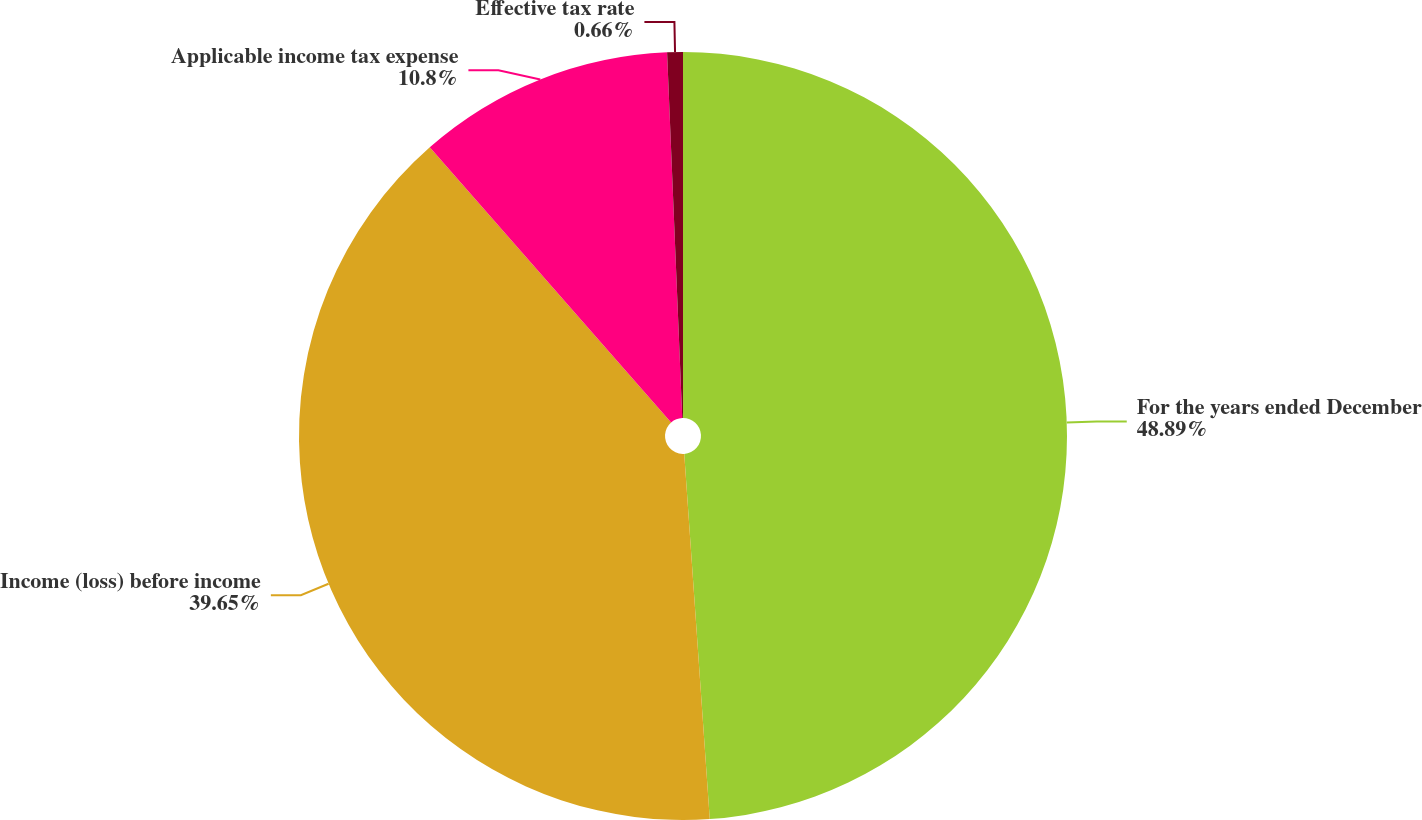Convert chart. <chart><loc_0><loc_0><loc_500><loc_500><pie_chart><fcel>For the years ended December<fcel>Income (loss) before income<fcel>Applicable income tax expense<fcel>Effective tax rate<nl><fcel>48.89%<fcel>39.65%<fcel>10.8%<fcel>0.66%<nl></chart> 